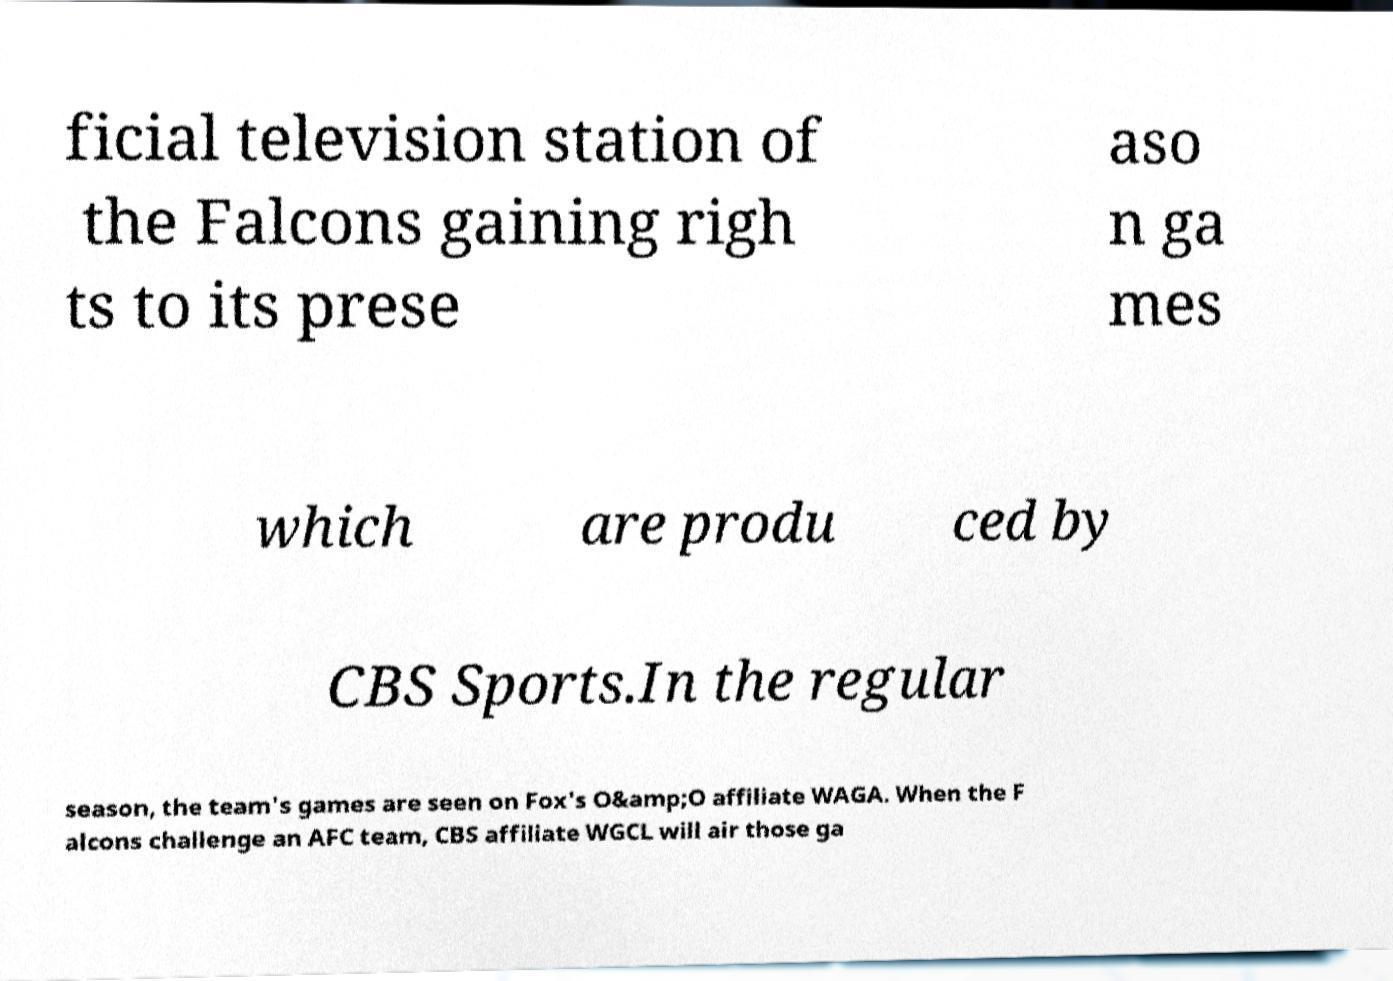What messages or text are displayed in this image? I need them in a readable, typed format. ficial television station of the Falcons gaining righ ts to its prese aso n ga mes which are produ ced by CBS Sports.In the regular season, the team's games are seen on Fox's O&amp;O affiliate WAGA. When the F alcons challenge an AFC team, CBS affiliate WGCL will air those ga 